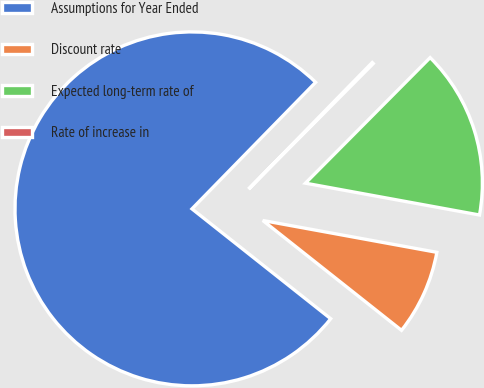Convert chart to OTSL. <chart><loc_0><loc_0><loc_500><loc_500><pie_chart><fcel>Assumptions for Year Ended<fcel>Discount rate<fcel>Expected long-term rate of<fcel>Rate of increase in<nl><fcel>76.65%<fcel>7.78%<fcel>15.43%<fcel>0.13%<nl></chart> 